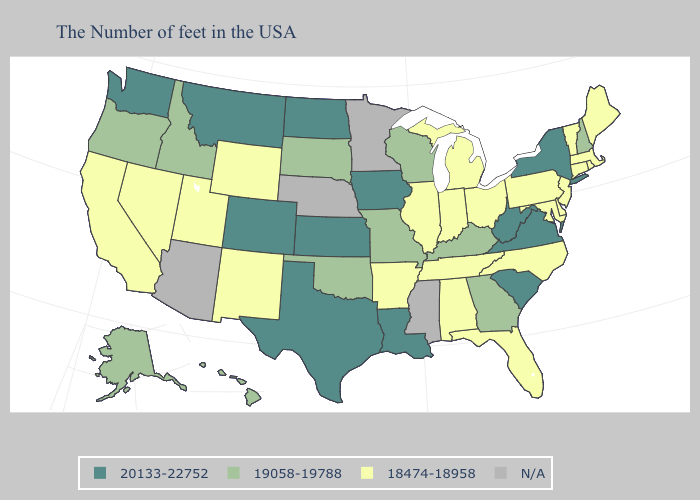What is the value of Virginia?
Answer briefly. 20133-22752. Name the states that have a value in the range 20133-22752?
Give a very brief answer. New York, Virginia, South Carolina, West Virginia, Louisiana, Iowa, Kansas, Texas, North Dakota, Colorado, Montana, Washington. Does Kansas have the lowest value in the USA?
Write a very short answer. No. Among the states that border Idaho , which have the highest value?
Be succinct. Montana, Washington. What is the value of Washington?
Concise answer only. 20133-22752. Which states have the highest value in the USA?
Answer briefly. New York, Virginia, South Carolina, West Virginia, Louisiana, Iowa, Kansas, Texas, North Dakota, Colorado, Montana, Washington. How many symbols are there in the legend?
Answer briefly. 4. Which states have the lowest value in the Northeast?
Quick response, please. Maine, Massachusetts, Rhode Island, Vermont, Connecticut, New Jersey, Pennsylvania. Name the states that have a value in the range 20133-22752?
Keep it brief. New York, Virginia, South Carolina, West Virginia, Louisiana, Iowa, Kansas, Texas, North Dakota, Colorado, Montana, Washington. Name the states that have a value in the range 20133-22752?
Short answer required. New York, Virginia, South Carolina, West Virginia, Louisiana, Iowa, Kansas, Texas, North Dakota, Colorado, Montana, Washington. What is the highest value in states that border Virginia?
Short answer required. 20133-22752. What is the value of California?
Write a very short answer. 18474-18958. Does New York have the lowest value in the Northeast?
Quick response, please. No. Does Texas have the highest value in the South?
Keep it brief. Yes. 